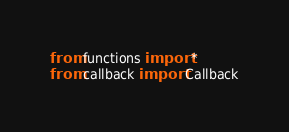<code> <loc_0><loc_0><loc_500><loc_500><_Python_>from functions import *
from callback import Callback
</code> 